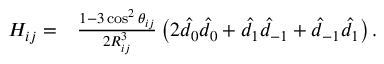Convert formula to latex. <formula><loc_0><loc_0><loc_500><loc_500>\begin{array} { r l } { H _ { i j } = } & \frac { 1 - 3 \cos ^ { 2 } \theta _ { i j } } { 2 R _ { i j } ^ { 3 } } \left ( 2 \hat { d } _ { 0 } \hat { d } _ { 0 } + \hat { d } _ { 1 } \hat { d } _ { - 1 } + \hat { d } _ { - 1 } \hat { d } _ { 1 } \right ) . } \end{array}</formula> 